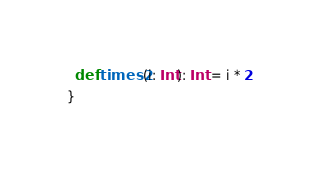Convert code to text. <code><loc_0><loc_0><loc_500><loc_500><_Scala_>  def times2(i: Int): Int = i * 2
}
</code> 